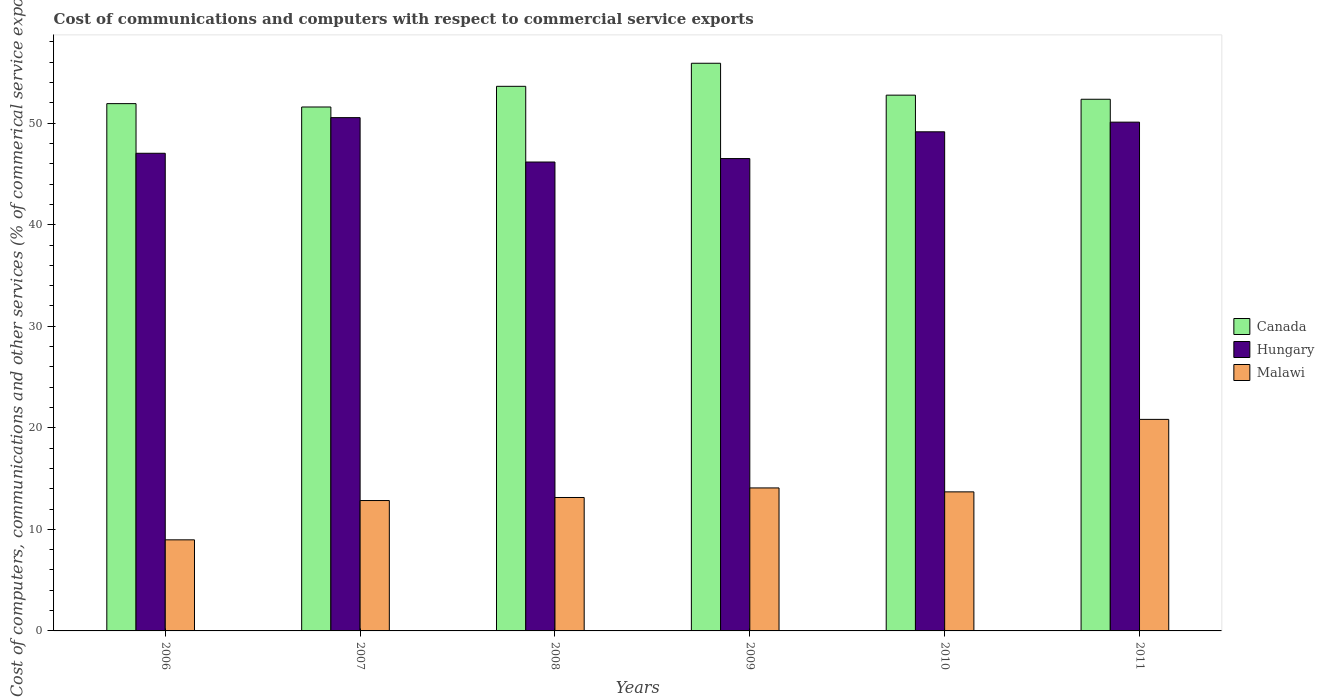How many groups of bars are there?
Give a very brief answer. 6. Are the number of bars on each tick of the X-axis equal?
Your response must be concise. Yes. How many bars are there on the 4th tick from the right?
Provide a succinct answer. 3. What is the label of the 6th group of bars from the left?
Your answer should be very brief. 2011. In how many cases, is the number of bars for a given year not equal to the number of legend labels?
Your answer should be compact. 0. What is the cost of communications and computers in Malawi in 2010?
Provide a short and direct response. 13.69. Across all years, what is the maximum cost of communications and computers in Hungary?
Ensure brevity in your answer.  50.55. Across all years, what is the minimum cost of communications and computers in Canada?
Offer a terse response. 51.6. In which year was the cost of communications and computers in Malawi maximum?
Make the answer very short. 2011. In which year was the cost of communications and computers in Hungary minimum?
Your answer should be very brief. 2008. What is the total cost of communications and computers in Canada in the graph?
Provide a succinct answer. 318.18. What is the difference between the cost of communications and computers in Hungary in 2007 and that in 2011?
Make the answer very short. 0.45. What is the difference between the cost of communications and computers in Canada in 2011 and the cost of communications and computers in Hungary in 2008?
Your response must be concise. 6.18. What is the average cost of communications and computers in Malawi per year?
Keep it short and to the point. 13.93. In the year 2011, what is the difference between the cost of communications and computers in Hungary and cost of communications and computers in Malawi?
Make the answer very short. 29.27. What is the ratio of the cost of communications and computers in Malawi in 2006 to that in 2008?
Make the answer very short. 0.68. Is the cost of communications and computers in Hungary in 2007 less than that in 2008?
Provide a succinct answer. No. What is the difference between the highest and the second highest cost of communications and computers in Canada?
Offer a terse response. 2.27. What is the difference between the highest and the lowest cost of communications and computers in Malawi?
Your answer should be very brief. 11.86. What does the 1st bar from the right in 2007 represents?
Offer a terse response. Malawi. How many bars are there?
Your answer should be compact. 18. Are all the bars in the graph horizontal?
Make the answer very short. No. Are the values on the major ticks of Y-axis written in scientific E-notation?
Provide a short and direct response. No. What is the title of the graph?
Your answer should be very brief. Cost of communications and computers with respect to commercial service exports. What is the label or title of the X-axis?
Ensure brevity in your answer.  Years. What is the label or title of the Y-axis?
Your response must be concise. Cost of computers, communications and other services (% of commerical service exports). What is the Cost of computers, communications and other services (% of commerical service exports) of Canada in 2006?
Your answer should be compact. 51.93. What is the Cost of computers, communications and other services (% of commerical service exports) in Hungary in 2006?
Offer a very short reply. 47.04. What is the Cost of computers, communications and other services (% of commerical service exports) of Malawi in 2006?
Provide a succinct answer. 8.97. What is the Cost of computers, communications and other services (% of commerical service exports) of Canada in 2007?
Offer a terse response. 51.6. What is the Cost of computers, communications and other services (% of commerical service exports) in Hungary in 2007?
Your response must be concise. 50.55. What is the Cost of computers, communications and other services (% of commerical service exports) in Malawi in 2007?
Provide a succinct answer. 12.84. What is the Cost of computers, communications and other services (% of commerical service exports) in Canada in 2008?
Your answer should be compact. 53.63. What is the Cost of computers, communications and other services (% of commerical service exports) in Hungary in 2008?
Offer a terse response. 46.18. What is the Cost of computers, communications and other services (% of commerical service exports) of Malawi in 2008?
Keep it short and to the point. 13.14. What is the Cost of computers, communications and other services (% of commerical service exports) of Canada in 2009?
Ensure brevity in your answer.  55.9. What is the Cost of computers, communications and other services (% of commerical service exports) in Hungary in 2009?
Provide a short and direct response. 46.52. What is the Cost of computers, communications and other services (% of commerical service exports) in Malawi in 2009?
Ensure brevity in your answer.  14.08. What is the Cost of computers, communications and other services (% of commerical service exports) in Canada in 2010?
Offer a terse response. 52.76. What is the Cost of computers, communications and other services (% of commerical service exports) in Hungary in 2010?
Give a very brief answer. 49.15. What is the Cost of computers, communications and other services (% of commerical service exports) in Malawi in 2010?
Your response must be concise. 13.69. What is the Cost of computers, communications and other services (% of commerical service exports) in Canada in 2011?
Provide a short and direct response. 52.36. What is the Cost of computers, communications and other services (% of commerical service exports) of Hungary in 2011?
Your response must be concise. 50.1. What is the Cost of computers, communications and other services (% of commerical service exports) in Malawi in 2011?
Your response must be concise. 20.83. Across all years, what is the maximum Cost of computers, communications and other services (% of commerical service exports) in Canada?
Your answer should be compact. 55.9. Across all years, what is the maximum Cost of computers, communications and other services (% of commerical service exports) of Hungary?
Your answer should be very brief. 50.55. Across all years, what is the maximum Cost of computers, communications and other services (% of commerical service exports) of Malawi?
Provide a succinct answer. 20.83. Across all years, what is the minimum Cost of computers, communications and other services (% of commerical service exports) in Canada?
Offer a terse response. 51.6. Across all years, what is the minimum Cost of computers, communications and other services (% of commerical service exports) in Hungary?
Give a very brief answer. 46.18. Across all years, what is the minimum Cost of computers, communications and other services (% of commerical service exports) in Malawi?
Offer a terse response. 8.97. What is the total Cost of computers, communications and other services (% of commerical service exports) of Canada in the graph?
Offer a terse response. 318.18. What is the total Cost of computers, communications and other services (% of commerical service exports) of Hungary in the graph?
Keep it short and to the point. 289.54. What is the total Cost of computers, communications and other services (% of commerical service exports) in Malawi in the graph?
Provide a succinct answer. 83.56. What is the difference between the Cost of computers, communications and other services (% of commerical service exports) in Canada in 2006 and that in 2007?
Keep it short and to the point. 0.33. What is the difference between the Cost of computers, communications and other services (% of commerical service exports) of Hungary in 2006 and that in 2007?
Your answer should be very brief. -3.51. What is the difference between the Cost of computers, communications and other services (% of commerical service exports) in Malawi in 2006 and that in 2007?
Make the answer very short. -3.87. What is the difference between the Cost of computers, communications and other services (% of commerical service exports) in Canada in 2006 and that in 2008?
Your response must be concise. -1.71. What is the difference between the Cost of computers, communications and other services (% of commerical service exports) of Hungary in 2006 and that in 2008?
Your answer should be compact. 0.86. What is the difference between the Cost of computers, communications and other services (% of commerical service exports) of Malawi in 2006 and that in 2008?
Offer a terse response. -4.17. What is the difference between the Cost of computers, communications and other services (% of commerical service exports) of Canada in 2006 and that in 2009?
Your response must be concise. -3.98. What is the difference between the Cost of computers, communications and other services (% of commerical service exports) in Hungary in 2006 and that in 2009?
Your response must be concise. 0.52. What is the difference between the Cost of computers, communications and other services (% of commerical service exports) of Malawi in 2006 and that in 2009?
Your answer should be compact. -5.11. What is the difference between the Cost of computers, communications and other services (% of commerical service exports) of Canada in 2006 and that in 2010?
Ensure brevity in your answer.  -0.84. What is the difference between the Cost of computers, communications and other services (% of commerical service exports) in Hungary in 2006 and that in 2010?
Your response must be concise. -2.11. What is the difference between the Cost of computers, communications and other services (% of commerical service exports) of Malawi in 2006 and that in 2010?
Provide a short and direct response. -4.72. What is the difference between the Cost of computers, communications and other services (% of commerical service exports) in Canada in 2006 and that in 2011?
Ensure brevity in your answer.  -0.43. What is the difference between the Cost of computers, communications and other services (% of commerical service exports) of Hungary in 2006 and that in 2011?
Your answer should be very brief. -3.06. What is the difference between the Cost of computers, communications and other services (% of commerical service exports) in Malawi in 2006 and that in 2011?
Your answer should be very brief. -11.86. What is the difference between the Cost of computers, communications and other services (% of commerical service exports) of Canada in 2007 and that in 2008?
Your answer should be compact. -2.04. What is the difference between the Cost of computers, communications and other services (% of commerical service exports) of Hungary in 2007 and that in 2008?
Your answer should be very brief. 4.37. What is the difference between the Cost of computers, communications and other services (% of commerical service exports) of Canada in 2007 and that in 2009?
Make the answer very short. -4.31. What is the difference between the Cost of computers, communications and other services (% of commerical service exports) in Hungary in 2007 and that in 2009?
Offer a terse response. 4.03. What is the difference between the Cost of computers, communications and other services (% of commerical service exports) of Malawi in 2007 and that in 2009?
Provide a short and direct response. -1.24. What is the difference between the Cost of computers, communications and other services (% of commerical service exports) in Canada in 2007 and that in 2010?
Make the answer very short. -1.17. What is the difference between the Cost of computers, communications and other services (% of commerical service exports) of Hungary in 2007 and that in 2010?
Make the answer very short. 1.4. What is the difference between the Cost of computers, communications and other services (% of commerical service exports) in Malawi in 2007 and that in 2010?
Your response must be concise. -0.85. What is the difference between the Cost of computers, communications and other services (% of commerical service exports) of Canada in 2007 and that in 2011?
Ensure brevity in your answer.  -0.76. What is the difference between the Cost of computers, communications and other services (% of commerical service exports) of Hungary in 2007 and that in 2011?
Offer a very short reply. 0.45. What is the difference between the Cost of computers, communications and other services (% of commerical service exports) of Malawi in 2007 and that in 2011?
Keep it short and to the point. -7.99. What is the difference between the Cost of computers, communications and other services (% of commerical service exports) in Canada in 2008 and that in 2009?
Keep it short and to the point. -2.27. What is the difference between the Cost of computers, communications and other services (% of commerical service exports) of Hungary in 2008 and that in 2009?
Give a very brief answer. -0.34. What is the difference between the Cost of computers, communications and other services (% of commerical service exports) of Malawi in 2008 and that in 2009?
Your answer should be compact. -0.94. What is the difference between the Cost of computers, communications and other services (% of commerical service exports) of Canada in 2008 and that in 2010?
Ensure brevity in your answer.  0.87. What is the difference between the Cost of computers, communications and other services (% of commerical service exports) of Hungary in 2008 and that in 2010?
Your answer should be compact. -2.98. What is the difference between the Cost of computers, communications and other services (% of commerical service exports) in Malawi in 2008 and that in 2010?
Offer a terse response. -0.55. What is the difference between the Cost of computers, communications and other services (% of commerical service exports) of Canada in 2008 and that in 2011?
Keep it short and to the point. 1.27. What is the difference between the Cost of computers, communications and other services (% of commerical service exports) of Hungary in 2008 and that in 2011?
Ensure brevity in your answer.  -3.93. What is the difference between the Cost of computers, communications and other services (% of commerical service exports) of Malawi in 2008 and that in 2011?
Give a very brief answer. -7.69. What is the difference between the Cost of computers, communications and other services (% of commerical service exports) in Canada in 2009 and that in 2010?
Offer a very short reply. 3.14. What is the difference between the Cost of computers, communications and other services (% of commerical service exports) in Hungary in 2009 and that in 2010?
Make the answer very short. -2.64. What is the difference between the Cost of computers, communications and other services (% of commerical service exports) in Malawi in 2009 and that in 2010?
Ensure brevity in your answer.  0.39. What is the difference between the Cost of computers, communications and other services (% of commerical service exports) in Canada in 2009 and that in 2011?
Your response must be concise. 3.55. What is the difference between the Cost of computers, communications and other services (% of commerical service exports) in Hungary in 2009 and that in 2011?
Provide a short and direct response. -3.59. What is the difference between the Cost of computers, communications and other services (% of commerical service exports) in Malawi in 2009 and that in 2011?
Offer a terse response. -6.75. What is the difference between the Cost of computers, communications and other services (% of commerical service exports) in Canada in 2010 and that in 2011?
Provide a succinct answer. 0.41. What is the difference between the Cost of computers, communications and other services (% of commerical service exports) of Hungary in 2010 and that in 2011?
Make the answer very short. -0.95. What is the difference between the Cost of computers, communications and other services (% of commerical service exports) of Malawi in 2010 and that in 2011?
Your answer should be compact. -7.14. What is the difference between the Cost of computers, communications and other services (% of commerical service exports) in Canada in 2006 and the Cost of computers, communications and other services (% of commerical service exports) in Hungary in 2007?
Your answer should be very brief. 1.38. What is the difference between the Cost of computers, communications and other services (% of commerical service exports) in Canada in 2006 and the Cost of computers, communications and other services (% of commerical service exports) in Malawi in 2007?
Your response must be concise. 39.09. What is the difference between the Cost of computers, communications and other services (% of commerical service exports) in Hungary in 2006 and the Cost of computers, communications and other services (% of commerical service exports) in Malawi in 2007?
Give a very brief answer. 34.2. What is the difference between the Cost of computers, communications and other services (% of commerical service exports) of Canada in 2006 and the Cost of computers, communications and other services (% of commerical service exports) of Hungary in 2008?
Your answer should be very brief. 5.75. What is the difference between the Cost of computers, communications and other services (% of commerical service exports) in Canada in 2006 and the Cost of computers, communications and other services (% of commerical service exports) in Malawi in 2008?
Your answer should be compact. 38.79. What is the difference between the Cost of computers, communications and other services (% of commerical service exports) in Hungary in 2006 and the Cost of computers, communications and other services (% of commerical service exports) in Malawi in 2008?
Keep it short and to the point. 33.9. What is the difference between the Cost of computers, communications and other services (% of commerical service exports) of Canada in 2006 and the Cost of computers, communications and other services (% of commerical service exports) of Hungary in 2009?
Ensure brevity in your answer.  5.41. What is the difference between the Cost of computers, communications and other services (% of commerical service exports) of Canada in 2006 and the Cost of computers, communications and other services (% of commerical service exports) of Malawi in 2009?
Keep it short and to the point. 37.85. What is the difference between the Cost of computers, communications and other services (% of commerical service exports) of Hungary in 2006 and the Cost of computers, communications and other services (% of commerical service exports) of Malawi in 2009?
Give a very brief answer. 32.96. What is the difference between the Cost of computers, communications and other services (% of commerical service exports) of Canada in 2006 and the Cost of computers, communications and other services (% of commerical service exports) of Hungary in 2010?
Provide a succinct answer. 2.77. What is the difference between the Cost of computers, communications and other services (% of commerical service exports) of Canada in 2006 and the Cost of computers, communications and other services (% of commerical service exports) of Malawi in 2010?
Make the answer very short. 38.23. What is the difference between the Cost of computers, communications and other services (% of commerical service exports) of Hungary in 2006 and the Cost of computers, communications and other services (% of commerical service exports) of Malawi in 2010?
Give a very brief answer. 33.35. What is the difference between the Cost of computers, communications and other services (% of commerical service exports) of Canada in 2006 and the Cost of computers, communications and other services (% of commerical service exports) of Hungary in 2011?
Offer a terse response. 1.82. What is the difference between the Cost of computers, communications and other services (% of commerical service exports) in Canada in 2006 and the Cost of computers, communications and other services (% of commerical service exports) in Malawi in 2011?
Provide a short and direct response. 31.09. What is the difference between the Cost of computers, communications and other services (% of commerical service exports) of Hungary in 2006 and the Cost of computers, communications and other services (% of commerical service exports) of Malawi in 2011?
Ensure brevity in your answer.  26.21. What is the difference between the Cost of computers, communications and other services (% of commerical service exports) of Canada in 2007 and the Cost of computers, communications and other services (% of commerical service exports) of Hungary in 2008?
Your answer should be compact. 5.42. What is the difference between the Cost of computers, communications and other services (% of commerical service exports) in Canada in 2007 and the Cost of computers, communications and other services (% of commerical service exports) in Malawi in 2008?
Offer a very short reply. 38.46. What is the difference between the Cost of computers, communications and other services (% of commerical service exports) in Hungary in 2007 and the Cost of computers, communications and other services (% of commerical service exports) in Malawi in 2008?
Your answer should be compact. 37.41. What is the difference between the Cost of computers, communications and other services (% of commerical service exports) in Canada in 2007 and the Cost of computers, communications and other services (% of commerical service exports) in Hungary in 2009?
Your response must be concise. 5.08. What is the difference between the Cost of computers, communications and other services (% of commerical service exports) of Canada in 2007 and the Cost of computers, communications and other services (% of commerical service exports) of Malawi in 2009?
Your response must be concise. 37.51. What is the difference between the Cost of computers, communications and other services (% of commerical service exports) of Hungary in 2007 and the Cost of computers, communications and other services (% of commerical service exports) of Malawi in 2009?
Provide a succinct answer. 36.47. What is the difference between the Cost of computers, communications and other services (% of commerical service exports) of Canada in 2007 and the Cost of computers, communications and other services (% of commerical service exports) of Hungary in 2010?
Your answer should be very brief. 2.44. What is the difference between the Cost of computers, communications and other services (% of commerical service exports) of Canada in 2007 and the Cost of computers, communications and other services (% of commerical service exports) of Malawi in 2010?
Make the answer very short. 37.9. What is the difference between the Cost of computers, communications and other services (% of commerical service exports) of Hungary in 2007 and the Cost of computers, communications and other services (% of commerical service exports) of Malawi in 2010?
Offer a terse response. 36.85. What is the difference between the Cost of computers, communications and other services (% of commerical service exports) in Canada in 2007 and the Cost of computers, communications and other services (% of commerical service exports) in Hungary in 2011?
Keep it short and to the point. 1.49. What is the difference between the Cost of computers, communications and other services (% of commerical service exports) in Canada in 2007 and the Cost of computers, communications and other services (% of commerical service exports) in Malawi in 2011?
Ensure brevity in your answer.  30.76. What is the difference between the Cost of computers, communications and other services (% of commerical service exports) in Hungary in 2007 and the Cost of computers, communications and other services (% of commerical service exports) in Malawi in 2011?
Your response must be concise. 29.72. What is the difference between the Cost of computers, communications and other services (% of commerical service exports) in Canada in 2008 and the Cost of computers, communications and other services (% of commerical service exports) in Hungary in 2009?
Offer a terse response. 7.12. What is the difference between the Cost of computers, communications and other services (% of commerical service exports) of Canada in 2008 and the Cost of computers, communications and other services (% of commerical service exports) of Malawi in 2009?
Keep it short and to the point. 39.55. What is the difference between the Cost of computers, communications and other services (% of commerical service exports) of Hungary in 2008 and the Cost of computers, communications and other services (% of commerical service exports) of Malawi in 2009?
Keep it short and to the point. 32.09. What is the difference between the Cost of computers, communications and other services (% of commerical service exports) of Canada in 2008 and the Cost of computers, communications and other services (% of commerical service exports) of Hungary in 2010?
Provide a succinct answer. 4.48. What is the difference between the Cost of computers, communications and other services (% of commerical service exports) in Canada in 2008 and the Cost of computers, communications and other services (% of commerical service exports) in Malawi in 2010?
Provide a succinct answer. 39.94. What is the difference between the Cost of computers, communications and other services (% of commerical service exports) of Hungary in 2008 and the Cost of computers, communications and other services (% of commerical service exports) of Malawi in 2010?
Ensure brevity in your answer.  32.48. What is the difference between the Cost of computers, communications and other services (% of commerical service exports) in Canada in 2008 and the Cost of computers, communications and other services (% of commerical service exports) in Hungary in 2011?
Your answer should be compact. 3.53. What is the difference between the Cost of computers, communications and other services (% of commerical service exports) in Canada in 2008 and the Cost of computers, communications and other services (% of commerical service exports) in Malawi in 2011?
Offer a very short reply. 32.8. What is the difference between the Cost of computers, communications and other services (% of commerical service exports) in Hungary in 2008 and the Cost of computers, communications and other services (% of commerical service exports) in Malawi in 2011?
Provide a succinct answer. 25.34. What is the difference between the Cost of computers, communications and other services (% of commerical service exports) of Canada in 2009 and the Cost of computers, communications and other services (% of commerical service exports) of Hungary in 2010?
Keep it short and to the point. 6.75. What is the difference between the Cost of computers, communications and other services (% of commerical service exports) in Canada in 2009 and the Cost of computers, communications and other services (% of commerical service exports) in Malawi in 2010?
Your answer should be very brief. 42.21. What is the difference between the Cost of computers, communications and other services (% of commerical service exports) of Hungary in 2009 and the Cost of computers, communications and other services (% of commerical service exports) of Malawi in 2010?
Provide a short and direct response. 32.82. What is the difference between the Cost of computers, communications and other services (% of commerical service exports) in Canada in 2009 and the Cost of computers, communications and other services (% of commerical service exports) in Hungary in 2011?
Offer a terse response. 5.8. What is the difference between the Cost of computers, communications and other services (% of commerical service exports) in Canada in 2009 and the Cost of computers, communications and other services (% of commerical service exports) in Malawi in 2011?
Your response must be concise. 35.07. What is the difference between the Cost of computers, communications and other services (% of commerical service exports) of Hungary in 2009 and the Cost of computers, communications and other services (% of commerical service exports) of Malawi in 2011?
Make the answer very short. 25.68. What is the difference between the Cost of computers, communications and other services (% of commerical service exports) in Canada in 2010 and the Cost of computers, communications and other services (% of commerical service exports) in Hungary in 2011?
Make the answer very short. 2.66. What is the difference between the Cost of computers, communications and other services (% of commerical service exports) of Canada in 2010 and the Cost of computers, communications and other services (% of commerical service exports) of Malawi in 2011?
Offer a very short reply. 31.93. What is the difference between the Cost of computers, communications and other services (% of commerical service exports) in Hungary in 2010 and the Cost of computers, communications and other services (% of commerical service exports) in Malawi in 2011?
Your answer should be very brief. 28.32. What is the average Cost of computers, communications and other services (% of commerical service exports) of Canada per year?
Your response must be concise. 53.03. What is the average Cost of computers, communications and other services (% of commerical service exports) of Hungary per year?
Your response must be concise. 48.26. What is the average Cost of computers, communications and other services (% of commerical service exports) of Malawi per year?
Make the answer very short. 13.93. In the year 2006, what is the difference between the Cost of computers, communications and other services (% of commerical service exports) of Canada and Cost of computers, communications and other services (% of commerical service exports) of Hungary?
Your answer should be compact. 4.89. In the year 2006, what is the difference between the Cost of computers, communications and other services (% of commerical service exports) of Canada and Cost of computers, communications and other services (% of commerical service exports) of Malawi?
Give a very brief answer. 42.96. In the year 2006, what is the difference between the Cost of computers, communications and other services (% of commerical service exports) of Hungary and Cost of computers, communications and other services (% of commerical service exports) of Malawi?
Give a very brief answer. 38.07. In the year 2007, what is the difference between the Cost of computers, communications and other services (% of commerical service exports) of Canada and Cost of computers, communications and other services (% of commerical service exports) of Hungary?
Keep it short and to the point. 1.05. In the year 2007, what is the difference between the Cost of computers, communications and other services (% of commerical service exports) in Canada and Cost of computers, communications and other services (% of commerical service exports) in Malawi?
Give a very brief answer. 38.76. In the year 2007, what is the difference between the Cost of computers, communications and other services (% of commerical service exports) in Hungary and Cost of computers, communications and other services (% of commerical service exports) in Malawi?
Offer a terse response. 37.71. In the year 2008, what is the difference between the Cost of computers, communications and other services (% of commerical service exports) of Canada and Cost of computers, communications and other services (% of commerical service exports) of Hungary?
Offer a very short reply. 7.46. In the year 2008, what is the difference between the Cost of computers, communications and other services (% of commerical service exports) in Canada and Cost of computers, communications and other services (% of commerical service exports) in Malawi?
Make the answer very short. 40.49. In the year 2008, what is the difference between the Cost of computers, communications and other services (% of commerical service exports) in Hungary and Cost of computers, communications and other services (% of commerical service exports) in Malawi?
Ensure brevity in your answer.  33.04. In the year 2009, what is the difference between the Cost of computers, communications and other services (% of commerical service exports) of Canada and Cost of computers, communications and other services (% of commerical service exports) of Hungary?
Keep it short and to the point. 9.39. In the year 2009, what is the difference between the Cost of computers, communications and other services (% of commerical service exports) in Canada and Cost of computers, communications and other services (% of commerical service exports) in Malawi?
Provide a succinct answer. 41.82. In the year 2009, what is the difference between the Cost of computers, communications and other services (% of commerical service exports) of Hungary and Cost of computers, communications and other services (% of commerical service exports) of Malawi?
Your answer should be very brief. 32.44. In the year 2010, what is the difference between the Cost of computers, communications and other services (% of commerical service exports) of Canada and Cost of computers, communications and other services (% of commerical service exports) of Hungary?
Ensure brevity in your answer.  3.61. In the year 2010, what is the difference between the Cost of computers, communications and other services (% of commerical service exports) in Canada and Cost of computers, communications and other services (% of commerical service exports) in Malawi?
Ensure brevity in your answer.  39.07. In the year 2010, what is the difference between the Cost of computers, communications and other services (% of commerical service exports) in Hungary and Cost of computers, communications and other services (% of commerical service exports) in Malawi?
Offer a very short reply. 35.46. In the year 2011, what is the difference between the Cost of computers, communications and other services (% of commerical service exports) in Canada and Cost of computers, communications and other services (% of commerical service exports) in Hungary?
Provide a short and direct response. 2.25. In the year 2011, what is the difference between the Cost of computers, communications and other services (% of commerical service exports) of Canada and Cost of computers, communications and other services (% of commerical service exports) of Malawi?
Provide a short and direct response. 31.53. In the year 2011, what is the difference between the Cost of computers, communications and other services (% of commerical service exports) of Hungary and Cost of computers, communications and other services (% of commerical service exports) of Malawi?
Ensure brevity in your answer.  29.27. What is the ratio of the Cost of computers, communications and other services (% of commerical service exports) in Canada in 2006 to that in 2007?
Make the answer very short. 1.01. What is the ratio of the Cost of computers, communications and other services (% of commerical service exports) of Hungary in 2006 to that in 2007?
Your answer should be very brief. 0.93. What is the ratio of the Cost of computers, communications and other services (% of commerical service exports) of Malawi in 2006 to that in 2007?
Keep it short and to the point. 0.7. What is the ratio of the Cost of computers, communications and other services (% of commerical service exports) of Canada in 2006 to that in 2008?
Offer a terse response. 0.97. What is the ratio of the Cost of computers, communications and other services (% of commerical service exports) of Hungary in 2006 to that in 2008?
Keep it short and to the point. 1.02. What is the ratio of the Cost of computers, communications and other services (% of commerical service exports) of Malawi in 2006 to that in 2008?
Provide a short and direct response. 0.68. What is the ratio of the Cost of computers, communications and other services (% of commerical service exports) of Canada in 2006 to that in 2009?
Your answer should be compact. 0.93. What is the ratio of the Cost of computers, communications and other services (% of commerical service exports) in Hungary in 2006 to that in 2009?
Keep it short and to the point. 1.01. What is the ratio of the Cost of computers, communications and other services (% of commerical service exports) of Malawi in 2006 to that in 2009?
Offer a very short reply. 0.64. What is the ratio of the Cost of computers, communications and other services (% of commerical service exports) in Canada in 2006 to that in 2010?
Keep it short and to the point. 0.98. What is the ratio of the Cost of computers, communications and other services (% of commerical service exports) of Malawi in 2006 to that in 2010?
Provide a short and direct response. 0.66. What is the ratio of the Cost of computers, communications and other services (% of commerical service exports) in Hungary in 2006 to that in 2011?
Make the answer very short. 0.94. What is the ratio of the Cost of computers, communications and other services (% of commerical service exports) in Malawi in 2006 to that in 2011?
Provide a short and direct response. 0.43. What is the ratio of the Cost of computers, communications and other services (% of commerical service exports) of Hungary in 2007 to that in 2008?
Provide a succinct answer. 1.09. What is the ratio of the Cost of computers, communications and other services (% of commerical service exports) in Malawi in 2007 to that in 2008?
Your response must be concise. 0.98. What is the ratio of the Cost of computers, communications and other services (% of commerical service exports) in Canada in 2007 to that in 2009?
Keep it short and to the point. 0.92. What is the ratio of the Cost of computers, communications and other services (% of commerical service exports) of Hungary in 2007 to that in 2009?
Your answer should be very brief. 1.09. What is the ratio of the Cost of computers, communications and other services (% of commerical service exports) of Malawi in 2007 to that in 2009?
Offer a terse response. 0.91. What is the ratio of the Cost of computers, communications and other services (% of commerical service exports) in Canada in 2007 to that in 2010?
Provide a succinct answer. 0.98. What is the ratio of the Cost of computers, communications and other services (% of commerical service exports) in Hungary in 2007 to that in 2010?
Provide a succinct answer. 1.03. What is the ratio of the Cost of computers, communications and other services (% of commerical service exports) of Malawi in 2007 to that in 2010?
Keep it short and to the point. 0.94. What is the ratio of the Cost of computers, communications and other services (% of commerical service exports) of Canada in 2007 to that in 2011?
Your response must be concise. 0.99. What is the ratio of the Cost of computers, communications and other services (% of commerical service exports) of Hungary in 2007 to that in 2011?
Your response must be concise. 1.01. What is the ratio of the Cost of computers, communications and other services (% of commerical service exports) of Malawi in 2007 to that in 2011?
Make the answer very short. 0.62. What is the ratio of the Cost of computers, communications and other services (% of commerical service exports) in Canada in 2008 to that in 2009?
Make the answer very short. 0.96. What is the ratio of the Cost of computers, communications and other services (% of commerical service exports) in Malawi in 2008 to that in 2009?
Provide a short and direct response. 0.93. What is the ratio of the Cost of computers, communications and other services (% of commerical service exports) of Canada in 2008 to that in 2010?
Provide a succinct answer. 1.02. What is the ratio of the Cost of computers, communications and other services (% of commerical service exports) in Hungary in 2008 to that in 2010?
Provide a succinct answer. 0.94. What is the ratio of the Cost of computers, communications and other services (% of commerical service exports) of Malawi in 2008 to that in 2010?
Your answer should be compact. 0.96. What is the ratio of the Cost of computers, communications and other services (% of commerical service exports) in Canada in 2008 to that in 2011?
Make the answer very short. 1.02. What is the ratio of the Cost of computers, communications and other services (% of commerical service exports) of Hungary in 2008 to that in 2011?
Provide a short and direct response. 0.92. What is the ratio of the Cost of computers, communications and other services (% of commerical service exports) in Malawi in 2008 to that in 2011?
Offer a terse response. 0.63. What is the ratio of the Cost of computers, communications and other services (% of commerical service exports) in Canada in 2009 to that in 2010?
Provide a succinct answer. 1.06. What is the ratio of the Cost of computers, communications and other services (% of commerical service exports) of Hungary in 2009 to that in 2010?
Offer a very short reply. 0.95. What is the ratio of the Cost of computers, communications and other services (% of commerical service exports) of Malawi in 2009 to that in 2010?
Offer a very short reply. 1.03. What is the ratio of the Cost of computers, communications and other services (% of commerical service exports) in Canada in 2009 to that in 2011?
Your response must be concise. 1.07. What is the ratio of the Cost of computers, communications and other services (% of commerical service exports) in Hungary in 2009 to that in 2011?
Offer a very short reply. 0.93. What is the ratio of the Cost of computers, communications and other services (% of commerical service exports) in Malawi in 2009 to that in 2011?
Provide a short and direct response. 0.68. What is the ratio of the Cost of computers, communications and other services (% of commerical service exports) of Canada in 2010 to that in 2011?
Provide a short and direct response. 1.01. What is the ratio of the Cost of computers, communications and other services (% of commerical service exports) in Hungary in 2010 to that in 2011?
Your answer should be compact. 0.98. What is the ratio of the Cost of computers, communications and other services (% of commerical service exports) of Malawi in 2010 to that in 2011?
Offer a terse response. 0.66. What is the difference between the highest and the second highest Cost of computers, communications and other services (% of commerical service exports) of Canada?
Offer a terse response. 2.27. What is the difference between the highest and the second highest Cost of computers, communications and other services (% of commerical service exports) in Hungary?
Your answer should be compact. 0.45. What is the difference between the highest and the second highest Cost of computers, communications and other services (% of commerical service exports) in Malawi?
Your answer should be compact. 6.75. What is the difference between the highest and the lowest Cost of computers, communications and other services (% of commerical service exports) in Canada?
Keep it short and to the point. 4.31. What is the difference between the highest and the lowest Cost of computers, communications and other services (% of commerical service exports) in Hungary?
Make the answer very short. 4.37. What is the difference between the highest and the lowest Cost of computers, communications and other services (% of commerical service exports) in Malawi?
Make the answer very short. 11.86. 